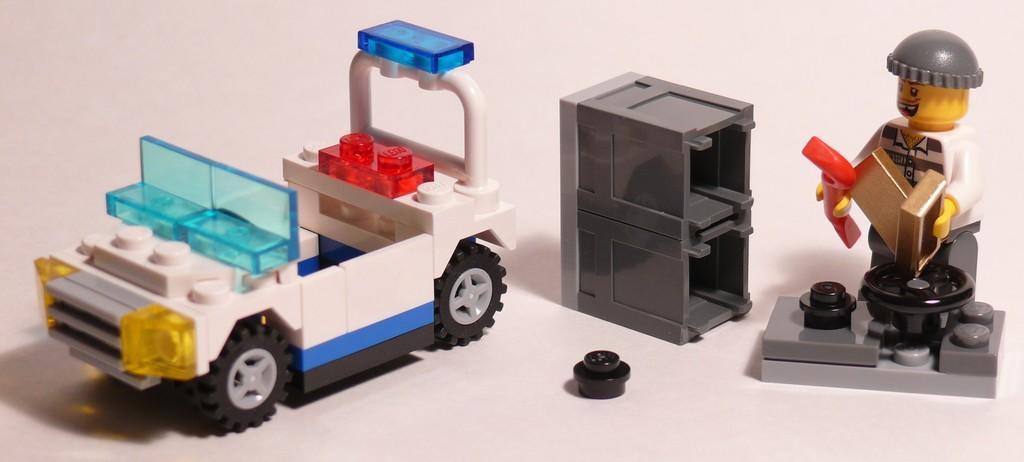In one or two sentences, can you explain what this image depicts? In this image we can see a toys of a vehicle, table and a man. 